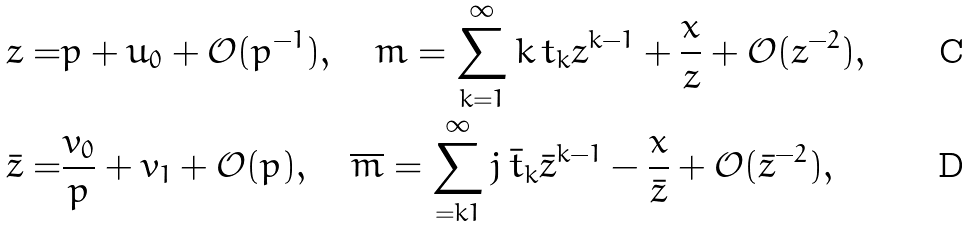<formula> <loc_0><loc_0><loc_500><loc_500>z = & p + u _ { 0 } + \mathcal { O } ( p ^ { - 1 } ) , \quad m = \sum _ { k = 1 } ^ { \infty } k \, t _ { k } z ^ { k - 1 } + \frac { x } { z } + \mathcal { O } ( z ^ { - 2 } ) , \\ \bar { z } = & \frac { v _ { 0 } } { p } + v _ { 1 } + \mathcal { O } ( p ) , \quad \overline { m } = \sum _ { = k 1 } ^ { \infty } j \, \bar { t } _ { k } \bar { z } ^ { k - 1 } - \frac { x } { \bar { z } } + \mathcal { O } ( \bar { z } ^ { - 2 } ) ,</formula> 